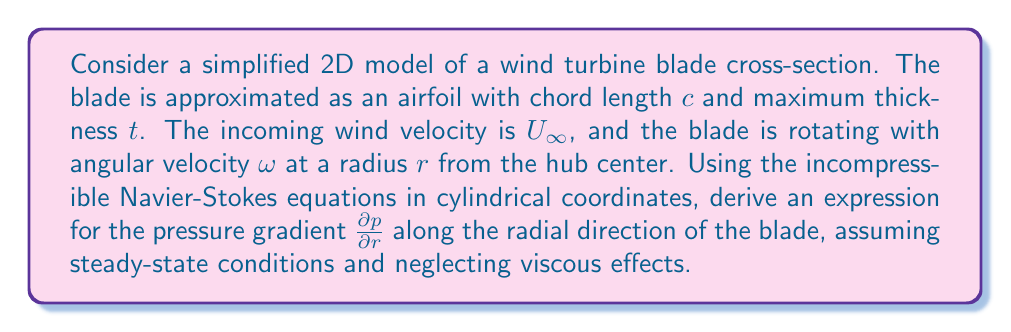Could you help me with this problem? To solve this problem, we'll follow these steps:

1. Write the Navier-Stokes equations in cylindrical coordinates.
2. Simplify the equations based on our assumptions.
3. Derive the expression for the pressure gradient.

Step 1: Navier-Stokes equations in cylindrical coordinates

The incompressible Navier-Stokes equations in cylindrical coordinates $(r, \theta, z)$ are:

Continuity equation:
$$\frac{1}{r}\frac{\partial (ru_r)}{\partial r} + \frac{1}{r}\frac{\partial u_\theta}{\partial \theta} + \frac{\partial u_z}{\partial z} = 0$$

Momentum equations:
$$\frac{\partial u_r}{\partial t} + u_r\frac{\partial u_r}{\partial r} + \frac{u_\theta}{r}\frac{\partial u_r}{\partial \theta} + u_z\frac{\partial u_r}{\partial z} - \frac{u_\theta^2}{r} = -\frac{1}{\rho}\frac{\partial p}{\partial r} + \nu\left(\nabla^2u_r - \frac{u_r}{r^2} - \frac{2}{r^2}\frac{\partial u_\theta}{\partial \theta}\right)$$

$$\frac{\partial u_\theta}{\partial t} + u_r\frac{\partial u_\theta}{\partial r} + \frac{u_\theta}{r}\frac{\partial u_\theta}{\partial \theta} + u_z\frac{\partial u_\theta}{\partial z} + \frac{u_ru_\theta}{r} = -\frac{1}{\rho r}\frac{\partial p}{\partial \theta} + \nu\left(\nabla^2u_\theta - \frac{u_\theta}{r^2} + \frac{2}{r^2}\frac{\partial u_r}{\partial \theta}\right)$$

$$\frac{\partial u_z}{\partial t} + u_r\frac{\partial u_z}{\partial r} + \frac{u_\theta}{r}\frac{\partial u_z}{\partial \theta} + u_z\frac{\partial u_z}{\partial z} = -\frac{1}{\rho}\frac{\partial p}{\partial z} + \nu\nabla^2u_z$$

Step 2: Simplify the equations

Given our assumptions:
- Steady-state conditions: $\frac{\partial}{\partial t} = 0$
- Neglecting viscous effects: $\nu = 0$
- 2D flow in the $r-\theta$ plane: $\frac{\partial}{\partial z} = 0$ and $u_z = 0$

The simplified equations become:

Continuity:
$$\frac{1}{r}\frac{\partial (ru_r)}{\partial r} + \frac{1}{r}\frac{\partial u_\theta}{\partial \theta} = 0$$

Radial momentum:
$$u_r\frac{\partial u_r}{\partial r} + \frac{u_\theta}{r}\frac{\partial u_r}{\partial \theta} - \frac{u_\theta^2}{r} = -\frac{1}{\rho}\frac{\partial p}{\partial r}$$

Tangential momentum:
$$u_r\frac{\partial u_\theta}{\partial r} + \frac{u_\theta}{r}\frac{\partial u_\theta}{\partial \theta} + \frac{u_ru_\theta}{r} = -\frac{1}{\rho r}\frac{\partial p}{\partial \theta}$$

Step 3: Derive the expression for the pressure gradient

We focus on the radial momentum equation to find $\frac{\partial p}{\partial r}$:

$$\frac{\partial p}{\partial r} = -\rho\left(u_r\frac{\partial u_r}{\partial r} + \frac{u_\theta}{r}\frac{\partial u_r}{\partial \theta} - \frac{u_\theta^2}{r}\right)$$

Now, we need to express $u_r$ and $u_\theta$ in terms of the given parameters:

- The relative velocity at the blade is the vector sum of the incoming wind velocity and the blade's rotational velocity:
  $u_r = U_{\infty}\cos\theta$
  $u_\theta = r\omega - U_{\infty}\sin\theta$

Substituting these into our equation:

$$\frac{\partial p}{\partial r} = -\rho\left(U_{\infty}\cos\theta\frac{\partial (U_{\infty}\cos\theta)}{\partial r} + \frac{r\omega - U_{\infty}\sin\theta}{r}\frac{\partial (U_{\infty}\cos\theta)}{\partial \theta} - \frac{(r\omega - U_{\infty}\sin\theta)^2}{r}\right)$$

Simplifying:

$$\frac{\partial p}{\partial r} = -\rho\left(0 + \frac{r\omega - U_{\infty}\sin\theta}{r}(-U_{\infty}\sin\theta) - \frac{r^2\omega^2 - 2r\omega U_{\infty}\sin\theta + U_{\infty}^2\sin^2\theta}{r}\right)$$

$$\frac{\partial p}{\partial r} = \rho\left(\frac{U_{\infty}^2\sin^2\theta - r\omega U_{\infty}\sin\theta}{r} + \frac{r^2\omega^2 - 2r\omega U_{\infty}\sin\theta + U_{\infty}^2\sin^2\theta}{r}\right)$$

Combining terms:

$$\frac{\partial p}{\partial r} = \rho\left(\frac{r^2\omega^2 - r\omega U_{\infty}\sin\theta + 2U_{\infty}^2\sin^2\theta}{r}\right)$$

This is our final expression for the pressure gradient along the radial direction of the wind turbine blade.
Answer: $$\frac{\partial p}{\partial r} = \rho\left(\frac{r^2\omega^2 - r\omega U_{\infty}\sin\theta + 2U_{\infty}^2\sin^2\theta}{r}\right)$$ 